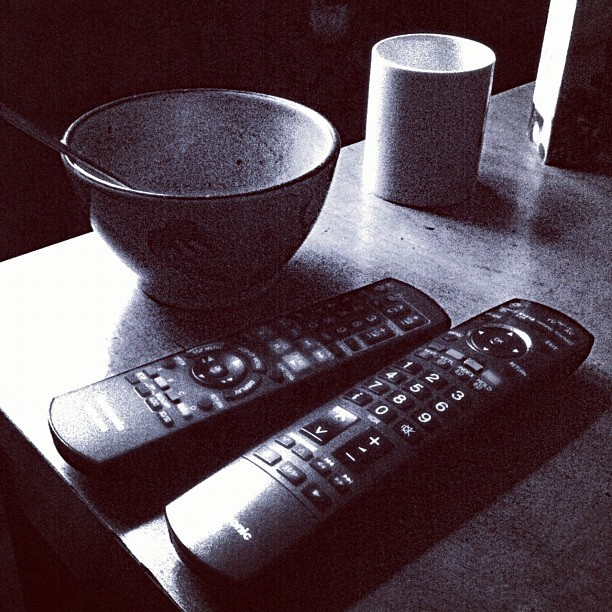Describe the objects in this image and their specific colors. I can see bowl in black, gray, and lightgray tones, remote in black, white, gray, and darkgray tones, remote in black, white, gray, and darkgray tones, cup in black, white, and darkgray tones, and spoon in black and gray tones in this image. 